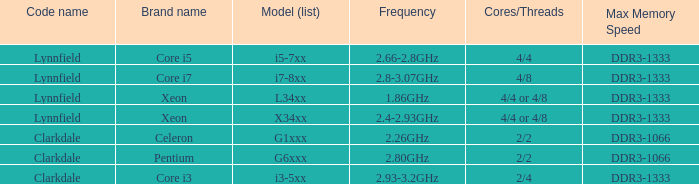What is the maximum memory speed for frequencies between 2.93-3.2ghz? DDR3-1333. Would you be able to parse every entry in this table? {'header': ['Code name', 'Brand name', 'Model (list)', 'Frequency', 'Cores/Threads', 'Max Memory Speed'], 'rows': [['Lynnfield', 'Core i5', 'i5-7xx', '2.66-2.8GHz', '4/4', 'DDR3-1333'], ['Lynnfield', 'Core i7', 'i7-8xx', '2.8-3.07GHz', '4/8', 'DDR3-1333'], ['Lynnfield', 'Xeon', 'L34xx', '1.86GHz', '4/4 or 4/8', 'DDR3-1333'], ['Lynnfield', 'Xeon', 'X34xx', '2.4-2.93GHz', '4/4 or 4/8', 'DDR3-1333'], ['Clarkdale', 'Celeron', 'G1xxx', '2.26GHz', '2/2', 'DDR3-1066'], ['Clarkdale', 'Pentium', 'G6xxx', '2.80GHz', '2/2', 'DDR3-1066'], ['Clarkdale', 'Core i3', 'i3-5xx', '2.93-3.2GHz', '2/4', 'DDR3-1333']]} 